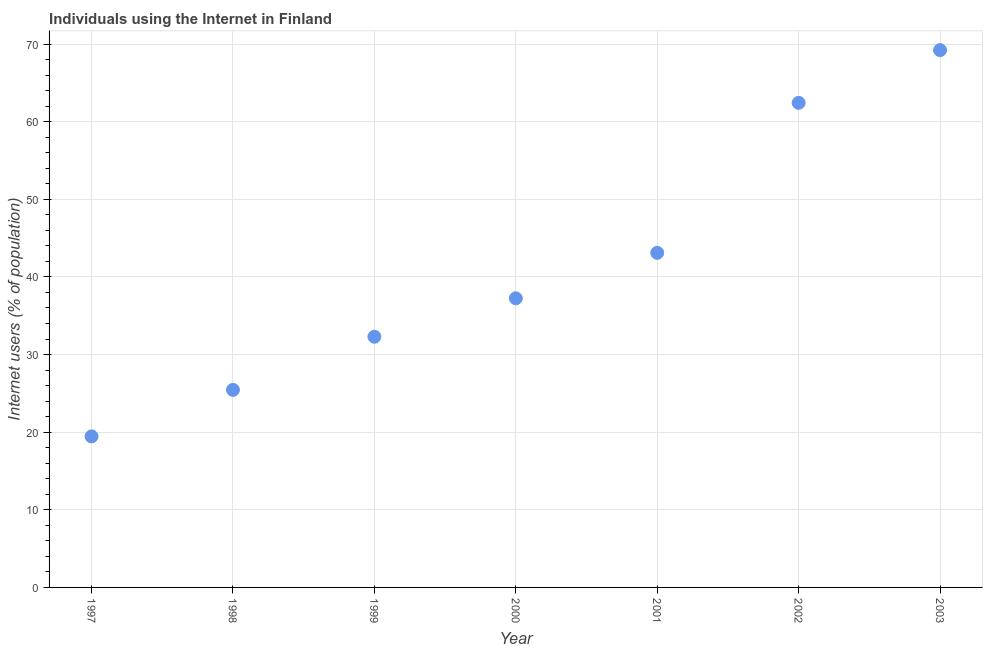What is the number of internet users in 2000?
Your answer should be very brief. 37.25. Across all years, what is the maximum number of internet users?
Provide a succinct answer. 69.22. Across all years, what is the minimum number of internet users?
Offer a very short reply. 19.46. In which year was the number of internet users minimum?
Provide a succinct answer. 1997. What is the sum of the number of internet users?
Keep it short and to the point. 289.21. What is the difference between the number of internet users in 2000 and 2002?
Ensure brevity in your answer.  -25.18. What is the average number of internet users per year?
Provide a succinct answer. 41.32. What is the median number of internet users?
Give a very brief answer. 37.25. In how many years, is the number of internet users greater than 36 %?
Your answer should be compact. 4. Do a majority of the years between 1999 and 2000 (inclusive) have number of internet users greater than 2 %?
Offer a very short reply. Yes. What is the ratio of the number of internet users in 1998 to that in 2000?
Your response must be concise. 0.68. Is the number of internet users in 1998 less than that in 2001?
Offer a very short reply. Yes. Is the difference between the number of internet users in 1998 and 1999 greater than the difference between any two years?
Ensure brevity in your answer.  No. What is the difference between the highest and the second highest number of internet users?
Keep it short and to the point. 6.79. What is the difference between the highest and the lowest number of internet users?
Your response must be concise. 49.76. In how many years, is the number of internet users greater than the average number of internet users taken over all years?
Keep it short and to the point. 3. How many dotlines are there?
Offer a terse response. 1. How many years are there in the graph?
Give a very brief answer. 7. Are the values on the major ticks of Y-axis written in scientific E-notation?
Offer a very short reply. No. Does the graph contain any zero values?
Make the answer very short. No. Does the graph contain grids?
Your response must be concise. Yes. What is the title of the graph?
Keep it short and to the point. Individuals using the Internet in Finland. What is the label or title of the X-axis?
Keep it short and to the point. Year. What is the label or title of the Y-axis?
Your answer should be very brief. Internet users (% of population). What is the Internet users (% of population) in 1997?
Your response must be concise. 19.46. What is the Internet users (% of population) in 1998?
Your answer should be compact. 25.45. What is the Internet users (% of population) in 1999?
Your answer should be compact. 32.3. What is the Internet users (% of population) in 2000?
Ensure brevity in your answer.  37.25. What is the Internet users (% of population) in 2001?
Offer a terse response. 43.11. What is the Internet users (% of population) in 2002?
Ensure brevity in your answer.  62.43. What is the Internet users (% of population) in 2003?
Make the answer very short. 69.22. What is the difference between the Internet users (% of population) in 1997 and 1998?
Make the answer very short. -5.99. What is the difference between the Internet users (% of population) in 1997 and 1999?
Give a very brief answer. -12.84. What is the difference between the Internet users (% of population) in 1997 and 2000?
Ensure brevity in your answer.  -17.79. What is the difference between the Internet users (% of population) in 1997 and 2001?
Offer a very short reply. -23.65. What is the difference between the Internet users (% of population) in 1997 and 2002?
Make the answer very short. -42.97. What is the difference between the Internet users (% of population) in 1997 and 2003?
Keep it short and to the point. -49.76. What is the difference between the Internet users (% of population) in 1998 and 1999?
Offer a very short reply. -6.84. What is the difference between the Internet users (% of population) in 1998 and 2000?
Offer a terse response. -11.8. What is the difference between the Internet users (% of population) in 1998 and 2001?
Ensure brevity in your answer.  -17.65. What is the difference between the Internet users (% of population) in 1998 and 2002?
Keep it short and to the point. -36.98. What is the difference between the Internet users (% of population) in 1998 and 2003?
Offer a very short reply. -43.77. What is the difference between the Internet users (% of population) in 1999 and 2000?
Keep it short and to the point. -4.95. What is the difference between the Internet users (% of population) in 1999 and 2001?
Ensure brevity in your answer.  -10.81. What is the difference between the Internet users (% of population) in 1999 and 2002?
Your response must be concise. -30.13. What is the difference between the Internet users (% of population) in 1999 and 2003?
Ensure brevity in your answer.  -36.92. What is the difference between the Internet users (% of population) in 2000 and 2001?
Keep it short and to the point. -5.86. What is the difference between the Internet users (% of population) in 2000 and 2002?
Your response must be concise. -25.18. What is the difference between the Internet users (% of population) in 2000 and 2003?
Provide a short and direct response. -31.97. What is the difference between the Internet users (% of population) in 2001 and 2002?
Your response must be concise. -19.32. What is the difference between the Internet users (% of population) in 2001 and 2003?
Give a very brief answer. -26.11. What is the difference between the Internet users (% of population) in 2002 and 2003?
Provide a short and direct response. -6.79. What is the ratio of the Internet users (% of population) in 1997 to that in 1998?
Provide a succinct answer. 0.77. What is the ratio of the Internet users (% of population) in 1997 to that in 1999?
Give a very brief answer. 0.6. What is the ratio of the Internet users (% of population) in 1997 to that in 2000?
Your response must be concise. 0.52. What is the ratio of the Internet users (% of population) in 1997 to that in 2001?
Your answer should be very brief. 0.45. What is the ratio of the Internet users (% of population) in 1997 to that in 2002?
Your answer should be very brief. 0.31. What is the ratio of the Internet users (% of population) in 1997 to that in 2003?
Your answer should be compact. 0.28. What is the ratio of the Internet users (% of population) in 1998 to that in 1999?
Your response must be concise. 0.79. What is the ratio of the Internet users (% of population) in 1998 to that in 2000?
Offer a terse response. 0.68. What is the ratio of the Internet users (% of population) in 1998 to that in 2001?
Your answer should be very brief. 0.59. What is the ratio of the Internet users (% of population) in 1998 to that in 2002?
Provide a short and direct response. 0.41. What is the ratio of the Internet users (% of population) in 1998 to that in 2003?
Give a very brief answer. 0.37. What is the ratio of the Internet users (% of population) in 1999 to that in 2000?
Provide a succinct answer. 0.87. What is the ratio of the Internet users (% of population) in 1999 to that in 2001?
Provide a succinct answer. 0.75. What is the ratio of the Internet users (% of population) in 1999 to that in 2002?
Offer a very short reply. 0.52. What is the ratio of the Internet users (% of population) in 1999 to that in 2003?
Give a very brief answer. 0.47. What is the ratio of the Internet users (% of population) in 2000 to that in 2001?
Keep it short and to the point. 0.86. What is the ratio of the Internet users (% of population) in 2000 to that in 2002?
Offer a terse response. 0.6. What is the ratio of the Internet users (% of population) in 2000 to that in 2003?
Make the answer very short. 0.54. What is the ratio of the Internet users (% of population) in 2001 to that in 2002?
Your answer should be compact. 0.69. What is the ratio of the Internet users (% of population) in 2001 to that in 2003?
Keep it short and to the point. 0.62. What is the ratio of the Internet users (% of population) in 2002 to that in 2003?
Your answer should be compact. 0.9. 